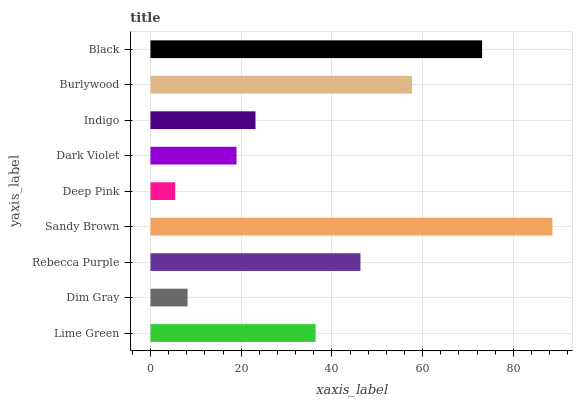Is Deep Pink the minimum?
Answer yes or no. Yes. Is Sandy Brown the maximum?
Answer yes or no. Yes. Is Dim Gray the minimum?
Answer yes or no. No. Is Dim Gray the maximum?
Answer yes or no. No. Is Lime Green greater than Dim Gray?
Answer yes or no. Yes. Is Dim Gray less than Lime Green?
Answer yes or no. Yes. Is Dim Gray greater than Lime Green?
Answer yes or no. No. Is Lime Green less than Dim Gray?
Answer yes or no. No. Is Lime Green the high median?
Answer yes or no. Yes. Is Lime Green the low median?
Answer yes or no. Yes. Is Indigo the high median?
Answer yes or no. No. Is Black the low median?
Answer yes or no. No. 